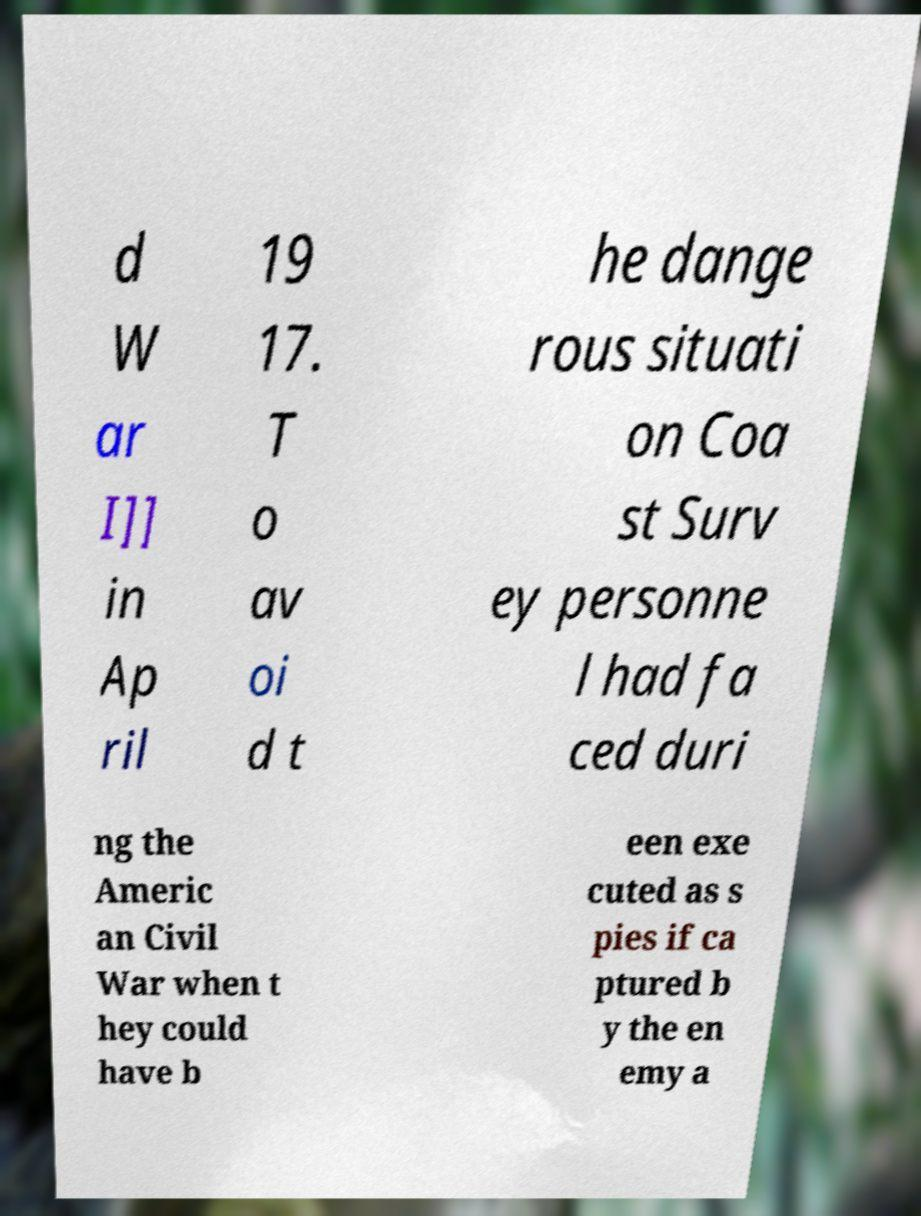Can you accurately transcribe the text from the provided image for me? d W ar I]] in Ap ril 19 17. T o av oi d t he dange rous situati on Coa st Surv ey personne l had fa ced duri ng the Americ an Civil War when t hey could have b een exe cuted as s pies if ca ptured b y the en emy a 